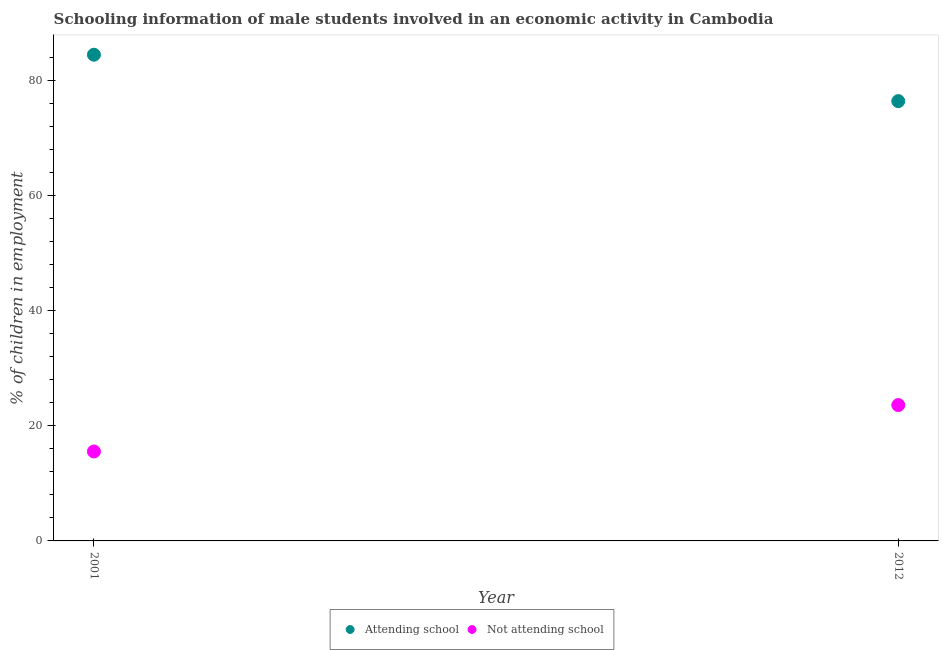How many different coloured dotlines are there?
Your answer should be very brief. 2. Is the number of dotlines equal to the number of legend labels?
Offer a very short reply. Yes. What is the percentage of employed males who are attending school in 2012?
Your answer should be compact. 76.4. Across all years, what is the maximum percentage of employed males who are not attending school?
Offer a terse response. 23.6. Across all years, what is the minimum percentage of employed males who are not attending school?
Make the answer very short. 15.54. What is the total percentage of employed males who are not attending school in the graph?
Provide a short and direct response. 39.14. What is the difference between the percentage of employed males who are not attending school in 2001 and that in 2012?
Your response must be concise. -8.06. What is the difference between the percentage of employed males who are attending school in 2001 and the percentage of employed males who are not attending school in 2012?
Keep it short and to the point. 60.86. What is the average percentage of employed males who are attending school per year?
Keep it short and to the point. 80.43. In the year 2012, what is the difference between the percentage of employed males who are attending school and percentage of employed males who are not attending school?
Make the answer very short. 52.8. In how many years, is the percentage of employed males who are attending school greater than 76 %?
Keep it short and to the point. 2. What is the ratio of the percentage of employed males who are attending school in 2001 to that in 2012?
Offer a terse response. 1.11. Is the percentage of employed males who are not attending school in 2001 less than that in 2012?
Provide a succinct answer. Yes. In how many years, is the percentage of employed males who are not attending school greater than the average percentage of employed males who are not attending school taken over all years?
Your answer should be compact. 1. Does the percentage of employed males who are attending school monotonically increase over the years?
Keep it short and to the point. No. Is the percentage of employed males who are not attending school strictly greater than the percentage of employed males who are attending school over the years?
Your answer should be very brief. No. How many years are there in the graph?
Your answer should be very brief. 2. What is the difference between two consecutive major ticks on the Y-axis?
Your answer should be very brief. 20. Are the values on the major ticks of Y-axis written in scientific E-notation?
Offer a terse response. No. Does the graph contain any zero values?
Give a very brief answer. No. How many legend labels are there?
Provide a succinct answer. 2. What is the title of the graph?
Provide a succinct answer. Schooling information of male students involved in an economic activity in Cambodia. Does "Passenger Transport Items" appear as one of the legend labels in the graph?
Your response must be concise. No. What is the label or title of the Y-axis?
Your answer should be very brief. % of children in employment. What is the % of children in employment in Attending school in 2001?
Provide a short and direct response. 84.46. What is the % of children in employment in Not attending school in 2001?
Give a very brief answer. 15.54. What is the % of children in employment in Attending school in 2012?
Provide a short and direct response. 76.4. What is the % of children in employment in Not attending school in 2012?
Keep it short and to the point. 23.6. Across all years, what is the maximum % of children in employment in Attending school?
Ensure brevity in your answer.  84.46. Across all years, what is the maximum % of children in employment of Not attending school?
Provide a short and direct response. 23.6. Across all years, what is the minimum % of children in employment in Attending school?
Offer a terse response. 76.4. Across all years, what is the minimum % of children in employment of Not attending school?
Your answer should be compact. 15.54. What is the total % of children in employment of Attending school in the graph?
Offer a very short reply. 160.86. What is the total % of children in employment in Not attending school in the graph?
Provide a short and direct response. 39.14. What is the difference between the % of children in employment of Attending school in 2001 and that in 2012?
Give a very brief answer. 8.06. What is the difference between the % of children in employment in Not attending school in 2001 and that in 2012?
Offer a terse response. -8.06. What is the difference between the % of children in employment of Attending school in 2001 and the % of children in employment of Not attending school in 2012?
Provide a short and direct response. 60.86. What is the average % of children in employment of Attending school per year?
Offer a terse response. 80.43. What is the average % of children in employment of Not attending school per year?
Your response must be concise. 19.57. In the year 2001, what is the difference between the % of children in employment in Attending school and % of children in employment in Not attending school?
Keep it short and to the point. 68.93. In the year 2012, what is the difference between the % of children in employment of Attending school and % of children in employment of Not attending school?
Ensure brevity in your answer.  52.8. What is the ratio of the % of children in employment of Attending school in 2001 to that in 2012?
Your answer should be very brief. 1.11. What is the ratio of the % of children in employment in Not attending school in 2001 to that in 2012?
Provide a succinct answer. 0.66. What is the difference between the highest and the second highest % of children in employment of Attending school?
Make the answer very short. 8.06. What is the difference between the highest and the second highest % of children in employment of Not attending school?
Your answer should be very brief. 8.06. What is the difference between the highest and the lowest % of children in employment in Attending school?
Keep it short and to the point. 8.06. What is the difference between the highest and the lowest % of children in employment in Not attending school?
Offer a terse response. 8.06. 